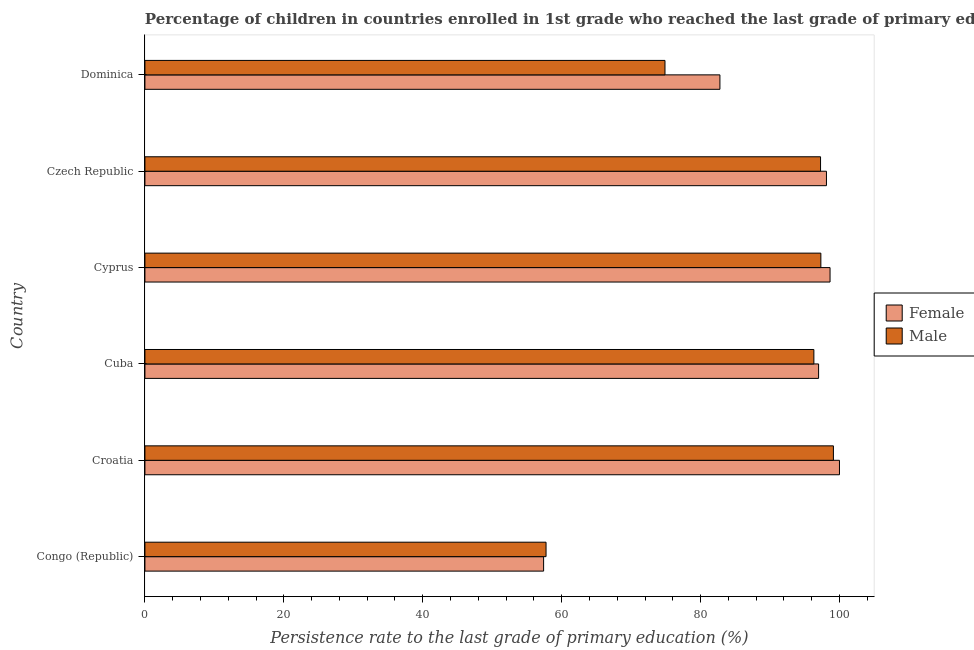How many bars are there on the 3rd tick from the bottom?
Keep it short and to the point. 2. What is the label of the 6th group of bars from the top?
Keep it short and to the point. Congo (Republic). In how many cases, is the number of bars for a given country not equal to the number of legend labels?
Provide a succinct answer. 0. What is the persistence rate of male students in Dominica?
Offer a very short reply. 74.88. Across all countries, what is the maximum persistence rate of male students?
Provide a short and direct response. 99.13. Across all countries, what is the minimum persistence rate of female students?
Your answer should be compact. 57.4. In which country was the persistence rate of female students maximum?
Your response must be concise. Croatia. In which country was the persistence rate of female students minimum?
Provide a short and direct response. Congo (Republic). What is the total persistence rate of female students in the graph?
Your answer should be very brief. 533.96. What is the difference between the persistence rate of male students in Croatia and that in Dominica?
Ensure brevity in your answer.  24.25. What is the difference between the persistence rate of male students in Cuba and the persistence rate of female students in Dominica?
Give a very brief answer. 13.53. What is the average persistence rate of male students per country?
Offer a very short reply. 87.11. What is the difference between the persistence rate of male students and persistence rate of female students in Dominica?
Offer a terse response. -7.91. What is the ratio of the persistence rate of male students in Czech Republic to that in Dominica?
Make the answer very short. 1.3. Is the difference between the persistence rate of female students in Cuba and Dominica greater than the difference between the persistence rate of male students in Cuba and Dominica?
Keep it short and to the point. No. What is the difference between the highest and the second highest persistence rate of female students?
Ensure brevity in your answer.  1.35. What is the difference between the highest and the lowest persistence rate of female students?
Keep it short and to the point. 42.6. In how many countries, is the persistence rate of male students greater than the average persistence rate of male students taken over all countries?
Give a very brief answer. 4. Is the sum of the persistence rate of female students in Congo (Republic) and Cuba greater than the maximum persistence rate of male students across all countries?
Offer a terse response. Yes. Does the graph contain grids?
Your answer should be very brief. No. Where does the legend appear in the graph?
Provide a short and direct response. Center right. How are the legend labels stacked?
Offer a terse response. Vertical. What is the title of the graph?
Give a very brief answer. Percentage of children in countries enrolled in 1st grade who reached the last grade of primary education. What is the label or title of the X-axis?
Your answer should be very brief. Persistence rate to the last grade of primary education (%). What is the label or title of the Y-axis?
Your answer should be compact. Country. What is the Persistence rate to the last grade of primary education (%) in Female in Congo (Republic)?
Provide a succinct answer. 57.4. What is the Persistence rate to the last grade of primary education (%) in Male in Congo (Republic)?
Your answer should be compact. 57.75. What is the Persistence rate to the last grade of primary education (%) in Male in Croatia?
Offer a very short reply. 99.13. What is the Persistence rate to the last grade of primary education (%) in Female in Cuba?
Ensure brevity in your answer.  96.99. What is the Persistence rate to the last grade of primary education (%) in Male in Cuba?
Offer a very short reply. 96.31. What is the Persistence rate to the last grade of primary education (%) of Female in Cyprus?
Provide a succinct answer. 98.64. What is the Persistence rate to the last grade of primary education (%) in Male in Cyprus?
Offer a terse response. 97.32. What is the Persistence rate to the last grade of primary education (%) in Female in Czech Republic?
Offer a very short reply. 98.13. What is the Persistence rate to the last grade of primary education (%) of Male in Czech Republic?
Ensure brevity in your answer.  97.27. What is the Persistence rate to the last grade of primary education (%) of Female in Dominica?
Your answer should be very brief. 82.79. What is the Persistence rate to the last grade of primary education (%) of Male in Dominica?
Your response must be concise. 74.88. Across all countries, what is the maximum Persistence rate to the last grade of primary education (%) in Male?
Offer a terse response. 99.13. Across all countries, what is the minimum Persistence rate to the last grade of primary education (%) in Female?
Make the answer very short. 57.4. Across all countries, what is the minimum Persistence rate to the last grade of primary education (%) in Male?
Ensure brevity in your answer.  57.75. What is the total Persistence rate to the last grade of primary education (%) in Female in the graph?
Provide a short and direct response. 533.96. What is the total Persistence rate to the last grade of primary education (%) in Male in the graph?
Provide a succinct answer. 522.67. What is the difference between the Persistence rate to the last grade of primary education (%) in Female in Congo (Republic) and that in Croatia?
Your answer should be very brief. -42.6. What is the difference between the Persistence rate to the last grade of primary education (%) of Male in Congo (Republic) and that in Croatia?
Your answer should be very brief. -41.37. What is the difference between the Persistence rate to the last grade of primary education (%) in Female in Congo (Republic) and that in Cuba?
Your response must be concise. -39.59. What is the difference between the Persistence rate to the last grade of primary education (%) in Male in Congo (Republic) and that in Cuba?
Offer a terse response. -38.56. What is the difference between the Persistence rate to the last grade of primary education (%) of Female in Congo (Republic) and that in Cyprus?
Ensure brevity in your answer.  -41.24. What is the difference between the Persistence rate to the last grade of primary education (%) of Male in Congo (Republic) and that in Cyprus?
Your answer should be very brief. -39.57. What is the difference between the Persistence rate to the last grade of primary education (%) in Female in Congo (Republic) and that in Czech Republic?
Offer a very short reply. -40.72. What is the difference between the Persistence rate to the last grade of primary education (%) in Male in Congo (Republic) and that in Czech Republic?
Your answer should be very brief. -39.52. What is the difference between the Persistence rate to the last grade of primary education (%) in Female in Congo (Republic) and that in Dominica?
Your response must be concise. -25.39. What is the difference between the Persistence rate to the last grade of primary education (%) of Male in Congo (Republic) and that in Dominica?
Provide a short and direct response. -17.12. What is the difference between the Persistence rate to the last grade of primary education (%) in Female in Croatia and that in Cuba?
Offer a terse response. 3.01. What is the difference between the Persistence rate to the last grade of primary education (%) in Male in Croatia and that in Cuba?
Make the answer very short. 2.81. What is the difference between the Persistence rate to the last grade of primary education (%) of Female in Croatia and that in Cyprus?
Your answer should be very brief. 1.36. What is the difference between the Persistence rate to the last grade of primary education (%) in Male in Croatia and that in Cyprus?
Give a very brief answer. 1.81. What is the difference between the Persistence rate to the last grade of primary education (%) of Female in Croatia and that in Czech Republic?
Your answer should be very brief. 1.87. What is the difference between the Persistence rate to the last grade of primary education (%) in Male in Croatia and that in Czech Republic?
Make the answer very short. 1.85. What is the difference between the Persistence rate to the last grade of primary education (%) in Female in Croatia and that in Dominica?
Your response must be concise. 17.21. What is the difference between the Persistence rate to the last grade of primary education (%) in Male in Croatia and that in Dominica?
Make the answer very short. 24.25. What is the difference between the Persistence rate to the last grade of primary education (%) in Female in Cuba and that in Cyprus?
Your answer should be compact. -1.65. What is the difference between the Persistence rate to the last grade of primary education (%) of Male in Cuba and that in Cyprus?
Your response must be concise. -1.01. What is the difference between the Persistence rate to the last grade of primary education (%) in Female in Cuba and that in Czech Republic?
Your answer should be compact. -1.13. What is the difference between the Persistence rate to the last grade of primary education (%) of Male in Cuba and that in Czech Republic?
Ensure brevity in your answer.  -0.96. What is the difference between the Persistence rate to the last grade of primary education (%) in Female in Cuba and that in Dominica?
Your answer should be very brief. 14.21. What is the difference between the Persistence rate to the last grade of primary education (%) in Male in Cuba and that in Dominica?
Your answer should be compact. 21.44. What is the difference between the Persistence rate to the last grade of primary education (%) in Female in Cyprus and that in Czech Republic?
Offer a very short reply. 0.52. What is the difference between the Persistence rate to the last grade of primary education (%) in Male in Cyprus and that in Czech Republic?
Give a very brief answer. 0.05. What is the difference between the Persistence rate to the last grade of primary education (%) in Female in Cyprus and that in Dominica?
Keep it short and to the point. 15.86. What is the difference between the Persistence rate to the last grade of primary education (%) of Male in Cyprus and that in Dominica?
Give a very brief answer. 22.44. What is the difference between the Persistence rate to the last grade of primary education (%) of Female in Czech Republic and that in Dominica?
Give a very brief answer. 15.34. What is the difference between the Persistence rate to the last grade of primary education (%) of Male in Czech Republic and that in Dominica?
Provide a short and direct response. 22.4. What is the difference between the Persistence rate to the last grade of primary education (%) in Female in Congo (Republic) and the Persistence rate to the last grade of primary education (%) in Male in Croatia?
Keep it short and to the point. -41.72. What is the difference between the Persistence rate to the last grade of primary education (%) of Female in Congo (Republic) and the Persistence rate to the last grade of primary education (%) of Male in Cuba?
Offer a terse response. -38.91. What is the difference between the Persistence rate to the last grade of primary education (%) of Female in Congo (Republic) and the Persistence rate to the last grade of primary education (%) of Male in Cyprus?
Your answer should be very brief. -39.92. What is the difference between the Persistence rate to the last grade of primary education (%) in Female in Congo (Republic) and the Persistence rate to the last grade of primary education (%) in Male in Czech Republic?
Give a very brief answer. -39.87. What is the difference between the Persistence rate to the last grade of primary education (%) of Female in Congo (Republic) and the Persistence rate to the last grade of primary education (%) of Male in Dominica?
Give a very brief answer. -17.48. What is the difference between the Persistence rate to the last grade of primary education (%) of Female in Croatia and the Persistence rate to the last grade of primary education (%) of Male in Cuba?
Provide a succinct answer. 3.69. What is the difference between the Persistence rate to the last grade of primary education (%) in Female in Croatia and the Persistence rate to the last grade of primary education (%) in Male in Cyprus?
Keep it short and to the point. 2.68. What is the difference between the Persistence rate to the last grade of primary education (%) of Female in Croatia and the Persistence rate to the last grade of primary education (%) of Male in Czech Republic?
Ensure brevity in your answer.  2.73. What is the difference between the Persistence rate to the last grade of primary education (%) of Female in Croatia and the Persistence rate to the last grade of primary education (%) of Male in Dominica?
Your answer should be very brief. 25.12. What is the difference between the Persistence rate to the last grade of primary education (%) in Female in Cuba and the Persistence rate to the last grade of primary education (%) in Male in Cyprus?
Provide a succinct answer. -0.33. What is the difference between the Persistence rate to the last grade of primary education (%) in Female in Cuba and the Persistence rate to the last grade of primary education (%) in Male in Czech Republic?
Provide a short and direct response. -0.28. What is the difference between the Persistence rate to the last grade of primary education (%) of Female in Cuba and the Persistence rate to the last grade of primary education (%) of Male in Dominica?
Your answer should be compact. 22.12. What is the difference between the Persistence rate to the last grade of primary education (%) of Female in Cyprus and the Persistence rate to the last grade of primary education (%) of Male in Czech Republic?
Your answer should be very brief. 1.37. What is the difference between the Persistence rate to the last grade of primary education (%) in Female in Cyprus and the Persistence rate to the last grade of primary education (%) in Male in Dominica?
Provide a short and direct response. 23.77. What is the difference between the Persistence rate to the last grade of primary education (%) of Female in Czech Republic and the Persistence rate to the last grade of primary education (%) of Male in Dominica?
Your response must be concise. 23.25. What is the average Persistence rate to the last grade of primary education (%) in Female per country?
Offer a very short reply. 88.99. What is the average Persistence rate to the last grade of primary education (%) in Male per country?
Give a very brief answer. 87.11. What is the difference between the Persistence rate to the last grade of primary education (%) of Female and Persistence rate to the last grade of primary education (%) of Male in Congo (Republic)?
Ensure brevity in your answer.  -0.35. What is the difference between the Persistence rate to the last grade of primary education (%) of Female and Persistence rate to the last grade of primary education (%) of Male in Croatia?
Offer a very short reply. 0.87. What is the difference between the Persistence rate to the last grade of primary education (%) in Female and Persistence rate to the last grade of primary education (%) in Male in Cuba?
Ensure brevity in your answer.  0.68. What is the difference between the Persistence rate to the last grade of primary education (%) in Female and Persistence rate to the last grade of primary education (%) in Male in Cyprus?
Your response must be concise. 1.32. What is the difference between the Persistence rate to the last grade of primary education (%) in Female and Persistence rate to the last grade of primary education (%) in Male in Czech Republic?
Your response must be concise. 0.85. What is the difference between the Persistence rate to the last grade of primary education (%) in Female and Persistence rate to the last grade of primary education (%) in Male in Dominica?
Make the answer very short. 7.91. What is the ratio of the Persistence rate to the last grade of primary education (%) in Female in Congo (Republic) to that in Croatia?
Offer a very short reply. 0.57. What is the ratio of the Persistence rate to the last grade of primary education (%) of Male in Congo (Republic) to that in Croatia?
Make the answer very short. 0.58. What is the ratio of the Persistence rate to the last grade of primary education (%) in Female in Congo (Republic) to that in Cuba?
Offer a terse response. 0.59. What is the ratio of the Persistence rate to the last grade of primary education (%) in Male in Congo (Republic) to that in Cuba?
Keep it short and to the point. 0.6. What is the ratio of the Persistence rate to the last grade of primary education (%) in Female in Congo (Republic) to that in Cyprus?
Offer a terse response. 0.58. What is the ratio of the Persistence rate to the last grade of primary education (%) of Male in Congo (Republic) to that in Cyprus?
Your answer should be compact. 0.59. What is the ratio of the Persistence rate to the last grade of primary education (%) in Female in Congo (Republic) to that in Czech Republic?
Make the answer very short. 0.58. What is the ratio of the Persistence rate to the last grade of primary education (%) in Male in Congo (Republic) to that in Czech Republic?
Your response must be concise. 0.59. What is the ratio of the Persistence rate to the last grade of primary education (%) in Female in Congo (Republic) to that in Dominica?
Offer a very short reply. 0.69. What is the ratio of the Persistence rate to the last grade of primary education (%) in Male in Congo (Republic) to that in Dominica?
Make the answer very short. 0.77. What is the ratio of the Persistence rate to the last grade of primary education (%) in Female in Croatia to that in Cuba?
Ensure brevity in your answer.  1.03. What is the ratio of the Persistence rate to the last grade of primary education (%) in Male in Croatia to that in Cuba?
Your response must be concise. 1.03. What is the ratio of the Persistence rate to the last grade of primary education (%) of Female in Croatia to that in Cyprus?
Provide a short and direct response. 1.01. What is the ratio of the Persistence rate to the last grade of primary education (%) of Male in Croatia to that in Cyprus?
Ensure brevity in your answer.  1.02. What is the ratio of the Persistence rate to the last grade of primary education (%) in Female in Croatia to that in Czech Republic?
Provide a short and direct response. 1.02. What is the ratio of the Persistence rate to the last grade of primary education (%) of Female in Croatia to that in Dominica?
Give a very brief answer. 1.21. What is the ratio of the Persistence rate to the last grade of primary education (%) of Male in Croatia to that in Dominica?
Provide a succinct answer. 1.32. What is the ratio of the Persistence rate to the last grade of primary education (%) of Female in Cuba to that in Cyprus?
Your answer should be compact. 0.98. What is the ratio of the Persistence rate to the last grade of primary education (%) of Male in Cuba to that in Cyprus?
Give a very brief answer. 0.99. What is the ratio of the Persistence rate to the last grade of primary education (%) in Male in Cuba to that in Czech Republic?
Make the answer very short. 0.99. What is the ratio of the Persistence rate to the last grade of primary education (%) in Female in Cuba to that in Dominica?
Your answer should be compact. 1.17. What is the ratio of the Persistence rate to the last grade of primary education (%) of Male in Cuba to that in Dominica?
Your answer should be very brief. 1.29. What is the ratio of the Persistence rate to the last grade of primary education (%) in Female in Cyprus to that in Czech Republic?
Offer a very short reply. 1.01. What is the ratio of the Persistence rate to the last grade of primary education (%) of Male in Cyprus to that in Czech Republic?
Provide a succinct answer. 1. What is the ratio of the Persistence rate to the last grade of primary education (%) of Female in Cyprus to that in Dominica?
Keep it short and to the point. 1.19. What is the ratio of the Persistence rate to the last grade of primary education (%) in Male in Cyprus to that in Dominica?
Your response must be concise. 1.3. What is the ratio of the Persistence rate to the last grade of primary education (%) of Female in Czech Republic to that in Dominica?
Your answer should be compact. 1.19. What is the ratio of the Persistence rate to the last grade of primary education (%) of Male in Czech Republic to that in Dominica?
Provide a succinct answer. 1.3. What is the difference between the highest and the second highest Persistence rate to the last grade of primary education (%) in Female?
Offer a very short reply. 1.36. What is the difference between the highest and the second highest Persistence rate to the last grade of primary education (%) of Male?
Offer a very short reply. 1.81. What is the difference between the highest and the lowest Persistence rate to the last grade of primary education (%) of Female?
Provide a short and direct response. 42.6. What is the difference between the highest and the lowest Persistence rate to the last grade of primary education (%) of Male?
Offer a terse response. 41.37. 